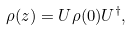Convert formula to latex. <formula><loc_0><loc_0><loc_500><loc_500>\rho ( z ) = U \rho ( 0 ) U ^ { \dag } ,</formula> 